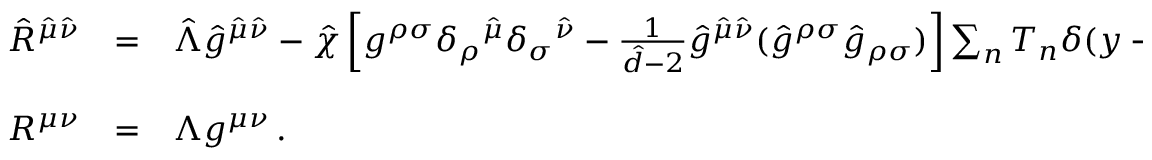Convert formula to latex. <formula><loc_0><loc_0><loc_500><loc_500>\begin{array} { r c l } { { \hat { R } ^ { \hat { \mu } \hat { \nu } } } } & { = } & { { \hat { \Lambda } \hat { g } ^ { \hat { \mu } \hat { \nu } } - \hat { \chi } \left [ g ^ { \rho \sigma } \delta _ { \rho ^ { \hat { \mu } } \delta _ { \sigma ^ { \hat { \nu } } - { \frac { 1 } { \hat { d } - 2 } } \hat { g } ^ { \hat { \mu } \hat { \nu } } ( \hat { g } ^ { \rho \sigma } \hat { g } _ { \rho \sigma } ) \right ] \sum _ { n } T _ { n } \delta ( y - y _ { n } ) \, , } } \\ { { R ^ { \mu \nu } } } & { = } & { { \Lambda g ^ { \mu \nu } \, . } } \end{array}</formula> 